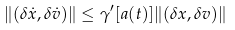Convert formula to latex. <formula><loc_0><loc_0><loc_500><loc_500>\| ( \delta \dot { x } , \delta \dot { v } ) \| \leq \gamma ^ { \prime } [ a ( t ) ] \| ( \delta x , \delta v ) \|</formula> 